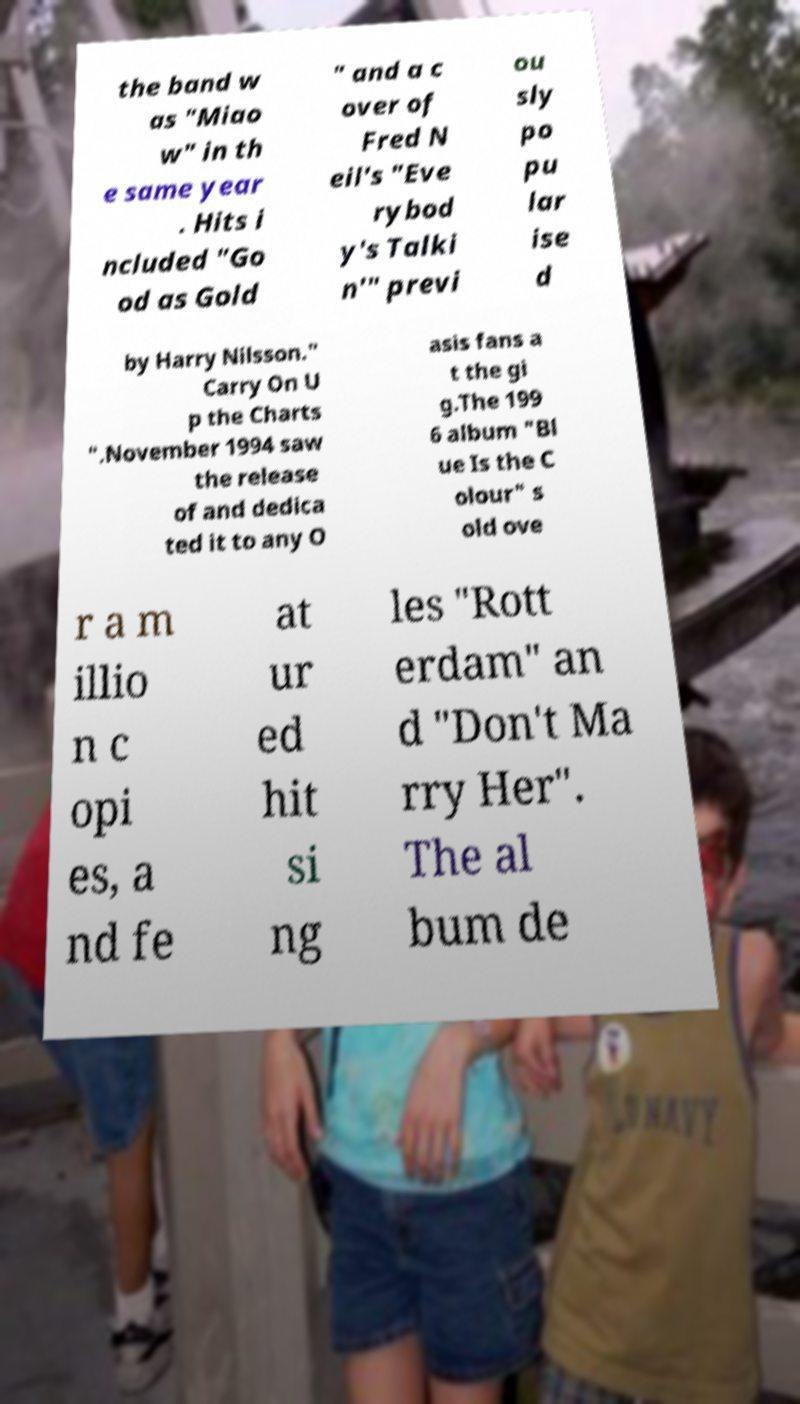Please read and relay the text visible in this image. What does it say? the band w as "Miao w" in th e same year . Hits i ncluded "Go od as Gold " and a c over of Fred N eil's "Eve rybod y's Talki n'" previ ou sly po pu lar ise d by Harry Nilsson." Carry On U p the Charts ".November 1994 saw the release of and dedica ted it to any O asis fans a t the gi g.The 199 6 album "Bl ue Is the C olour" s old ove r a m illio n c opi es, a nd fe at ur ed hit si ng les "Rott erdam" an d "Don't Ma rry Her". The al bum de 